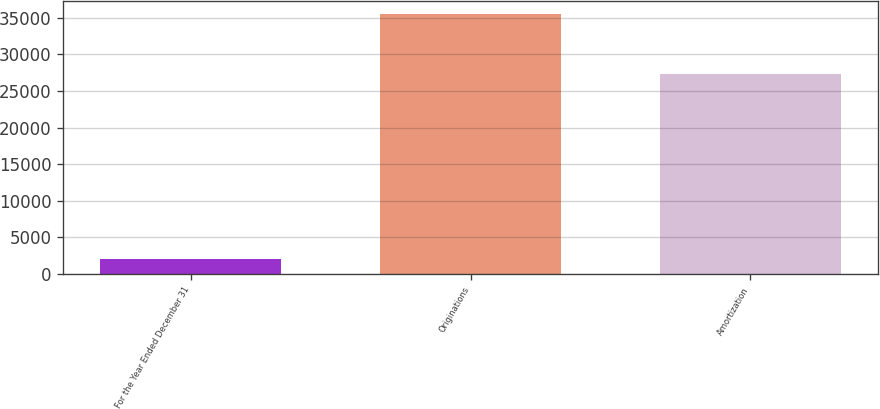<chart> <loc_0><loc_0><loc_500><loc_500><bar_chart><fcel>For the Year Ended December 31<fcel>Originations<fcel>Amortization<nl><fcel>2015<fcel>35556<fcel>27367<nl></chart> 